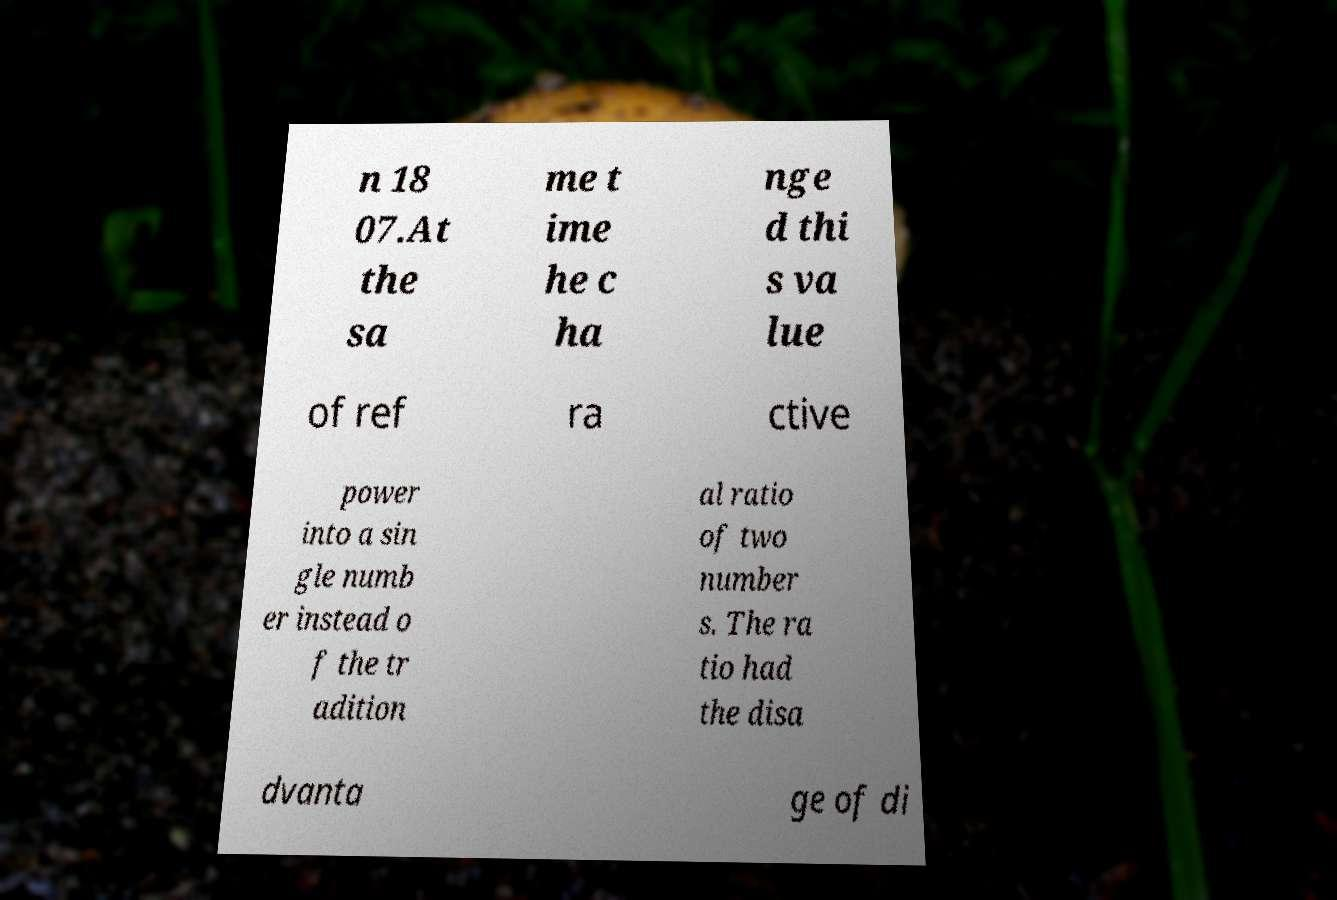I need the written content from this picture converted into text. Can you do that? n 18 07.At the sa me t ime he c ha nge d thi s va lue of ref ra ctive power into a sin gle numb er instead o f the tr adition al ratio of two number s. The ra tio had the disa dvanta ge of di 